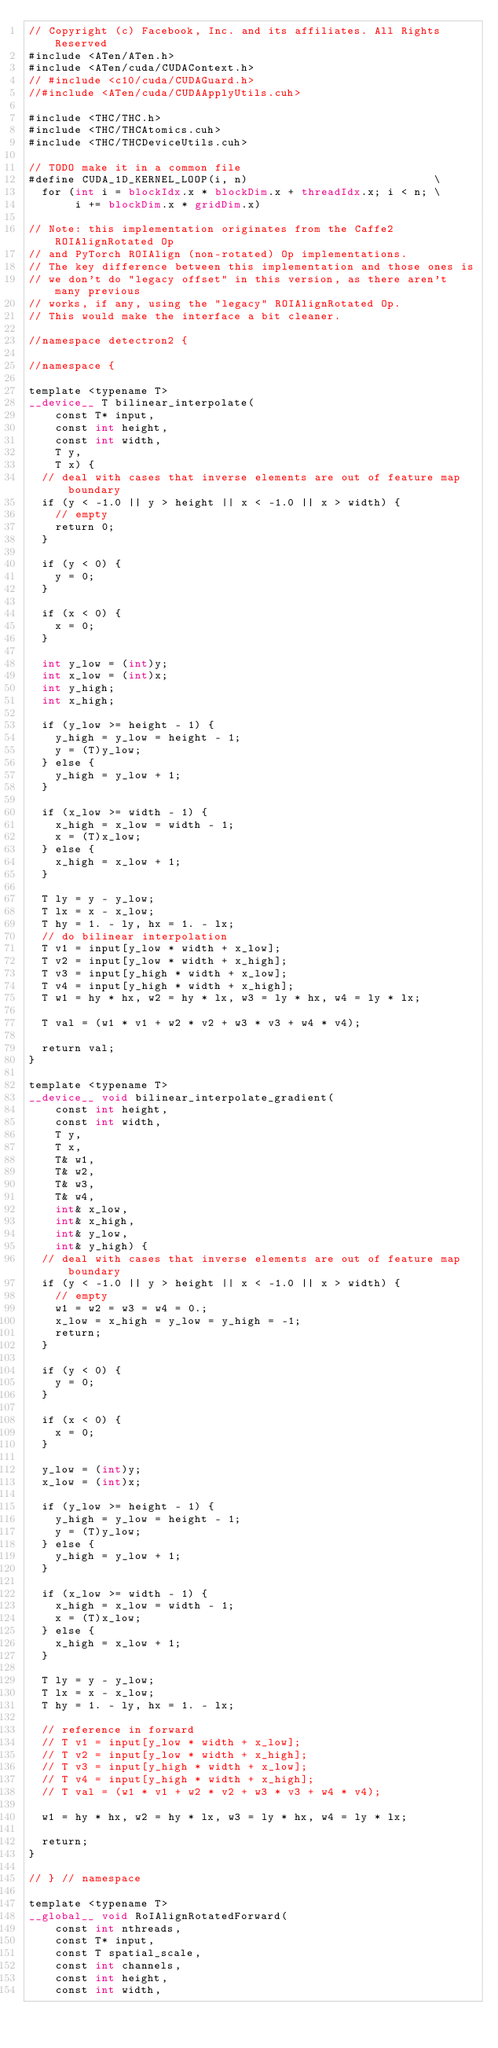<code> <loc_0><loc_0><loc_500><loc_500><_Cuda_>// Copyright (c) Facebook, Inc. and its affiliates. All Rights Reserved
#include <ATen/ATen.h>
#include <ATen/cuda/CUDAContext.h>
// #include <c10/cuda/CUDAGuard.h>
//#include <ATen/cuda/CUDAApplyUtils.cuh>

#include <THC/THC.h>
#include <THC/THCAtomics.cuh>
#include <THC/THCDeviceUtils.cuh>

// TODO make it in a common file
#define CUDA_1D_KERNEL_LOOP(i, n)                            \
  for (int i = blockIdx.x * blockDim.x + threadIdx.x; i < n; \
       i += blockDim.x * gridDim.x)

// Note: this implementation originates from the Caffe2 ROIAlignRotated Op
// and PyTorch ROIAlign (non-rotated) Op implementations.
// The key difference between this implementation and those ones is
// we don't do "legacy offset" in this version, as there aren't many previous
// works, if any, using the "legacy" ROIAlignRotated Op.
// This would make the interface a bit cleaner.

//namespace detectron2 {

//namespace {

template <typename T>
__device__ T bilinear_interpolate(
    const T* input,
    const int height,
    const int width,
    T y,
    T x) {
  // deal with cases that inverse elements are out of feature map boundary
  if (y < -1.0 || y > height || x < -1.0 || x > width) {
    // empty
    return 0;
  }

  if (y < 0) {
    y = 0;
  }

  if (x < 0) {
    x = 0;
  }

  int y_low = (int)y;
  int x_low = (int)x;
  int y_high;
  int x_high;

  if (y_low >= height - 1) {
    y_high = y_low = height - 1;
    y = (T)y_low;
  } else {
    y_high = y_low + 1;
  }

  if (x_low >= width - 1) {
    x_high = x_low = width - 1;
    x = (T)x_low;
  } else {
    x_high = x_low + 1;
  }

  T ly = y - y_low;
  T lx = x - x_low;
  T hy = 1. - ly, hx = 1. - lx;
  // do bilinear interpolation
  T v1 = input[y_low * width + x_low];
  T v2 = input[y_low * width + x_high];
  T v3 = input[y_high * width + x_low];
  T v4 = input[y_high * width + x_high];
  T w1 = hy * hx, w2 = hy * lx, w3 = ly * hx, w4 = ly * lx;

  T val = (w1 * v1 + w2 * v2 + w3 * v3 + w4 * v4);

  return val;
}

template <typename T>
__device__ void bilinear_interpolate_gradient(
    const int height,
    const int width,
    T y,
    T x,
    T& w1,
    T& w2,
    T& w3,
    T& w4,
    int& x_low,
    int& x_high,
    int& y_low,
    int& y_high) {
  // deal with cases that inverse elements are out of feature map boundary
  if (y < -1.0 || y > height || x < -1.0 || x > width) {
    // empty
    w1 = w2 = w3 = w4 = 0.;
    x_low = x_high = y_low = y_high = -1;
    return;
  }

  if (y < 0) {
    y = 0;
  }

  if (x < 0) {
    x = 0;
  }

  y_low = (int)y;
  x_low = (int)x;

  if (y_low >= height - 1) {
    y_high = y_low = height - 1;
    y = (T)y_low;
  } else {
    y_high = y_low + 1;
  }

  if (x_low >= width - 1) {
    x_high = x_low = width - 1;
    x = (T)x_low;
  } else {
    x_high = x_low + 1;
  }

  T ly = y - y_low;
  T lx = x - x_low;
  T hy = 1. - ly, hx = 1. - lx;

  // reference in forward
  // T v1 = input[y_low * width + x_low];
  // T v2 = input[y_low * width + x_high];
  // T v3 = input[y_high * width + x_low];
  // T v4 = input[y_high * width + x_high];
  // T val = (w1 * v1 + w2 * v2 + w3 * v3 + w4 * v4);

  w1 = hy * hx, w2 = hy * lx, w3 = ly * hx, w4 = ly * lx;

  return;
}

// } // namespace

template <typename T>
__global__ void RoIAlignRotatedForward(
    const int nthreads,
    const T* input,
    const T spatial_scale,
    const int channels,
    const int height,
    const int width,</code> 